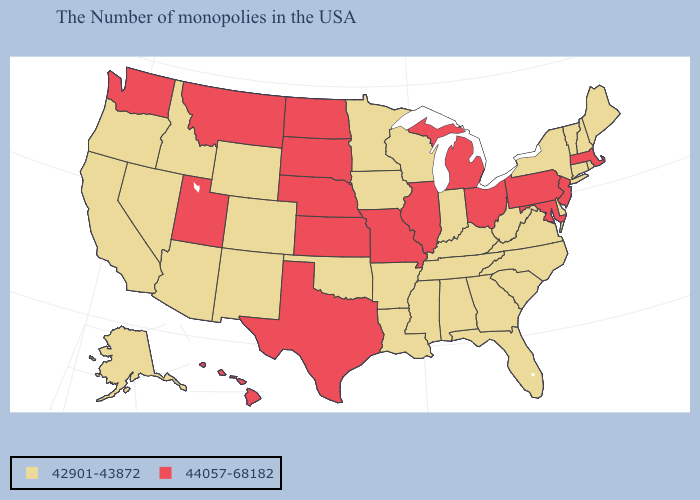What is the lowest value in the USA?
Short answer required. 42901-43872. What is the value of Vermont?
Concise answer only. 42901-43872. Does the map have missing data?
Quick response, please. No. Which states have the lowest value in the USA?
Concise answer only. Maine, Rhode Island, New Hampshire, Vermont, Connecticut, New York, Delaware, Virginia, North Carolina, South Carolina, West Virginia, Florida, Georgia, Kentucky, Indiana, Alabama, Tennessee, Wisconsin, Mississippi, Louisiana, Arkansas, Minnesota, Iowa, Oklahoma, Wyoming, Colorado, New Mexico, Arizona, Idaho, Nevada, California, Oregon, Alaska. Does Alaska have a higher value than Vermont?
Quick response, please. No. How many symbols are there in the legend?
Concise answer only. 2. Does the map have missing data?
Concise answer only. No. Name the states that have a value in the range 42901-43872?
Keep it brief. Maine, Rhode Island, New Hampshire, Vermont, Connecticut, New York, Delaware, Virginia, North Carolina, South Carolina, West Virginia, Florida, Georgia, Kentucky, Indiana, Alabama, Tennessee, Wisconsin, Mississippi, Louisiana, Arkansas, Minnesota, Iowa, Oklahoma, Wyoming, Colorado, New Mexico, Arizona, Idaho, Nevada, California, Oregon, Alaska. Which states have the lowest value in the USA?
Keep it brief. Maine, Rhode Island, New Hampshire, Vermont, Connecticut, New York, Delaware, Virginia, North Carolina, South Carolina, West Virginia, Florida, Georgia, Kentucky, Indiana, Alabama, Tennessee, Wisconsin, Mississippi, Louisiana, Arkansas, Minnesota, Iowa, Oklahoma, Wyoming, Colorado, New Mexico, Arizona, Idaho, Nevada, California, Oregon, Alaska. Name the states that have a value in the range 42901-43872?
Quick response, please. Maine, Rhode Island, New Hampshire, Vermont, Connecticut, New York, Delaware, Virginia, North Carolina, South Carolina, West Virginia, Florida, Georgia, Kentucky, Indiana, Alabama, Tennessee, Wisconsin, Mississippi, Louisiana, Arkansas, Minnesota, Iowa, Oklahoma, Wyoming, Colorado, New Mexico, Arizona, Idaho, Nevada, California, Oregon, Alaska. What is the value of Iowa?
Answer briefly. 42901-43872. Does Illinois have the lowest value in the USA?
Keep it brief. No. Name the states that have a value in the range 42901-43872?
Keep it brief. Maine, Rhode Island, New Hampshire, Vermont, Connecticut, New York, Delaware, Virginia, North Carolina, South Carolina, West Virginia, Florida, Georgia, Kentucky, Indiana, Alabama, Tennessee, Wisconsin, Mississippi, Louisiana, Arkansas, Minnesota, Iowa, Oklahoma, Wyoming, Colorado, New Mexico, Arizona, Idaho, Nevada, California, Oregon, Alaska. Name the states that have a value in the range 42901-43872?
Keep it brief. Maine, Rhode Island, New Hampshire, Vermont, Connecticut, New York, Delaware, Virginia, North Carolina, South Carolina, West Virginia, Florida, Georgia, Kentucky, Indiana, Alabama, Tennessee, Wisconsin, Mississippi, Louisiana, Arkansas, Minnesota, Iowa, Oklahoma, Wyoming, Colorado, New Mexico, Arizona, Idaho, Nevada, California, Oregon, Alaska. 